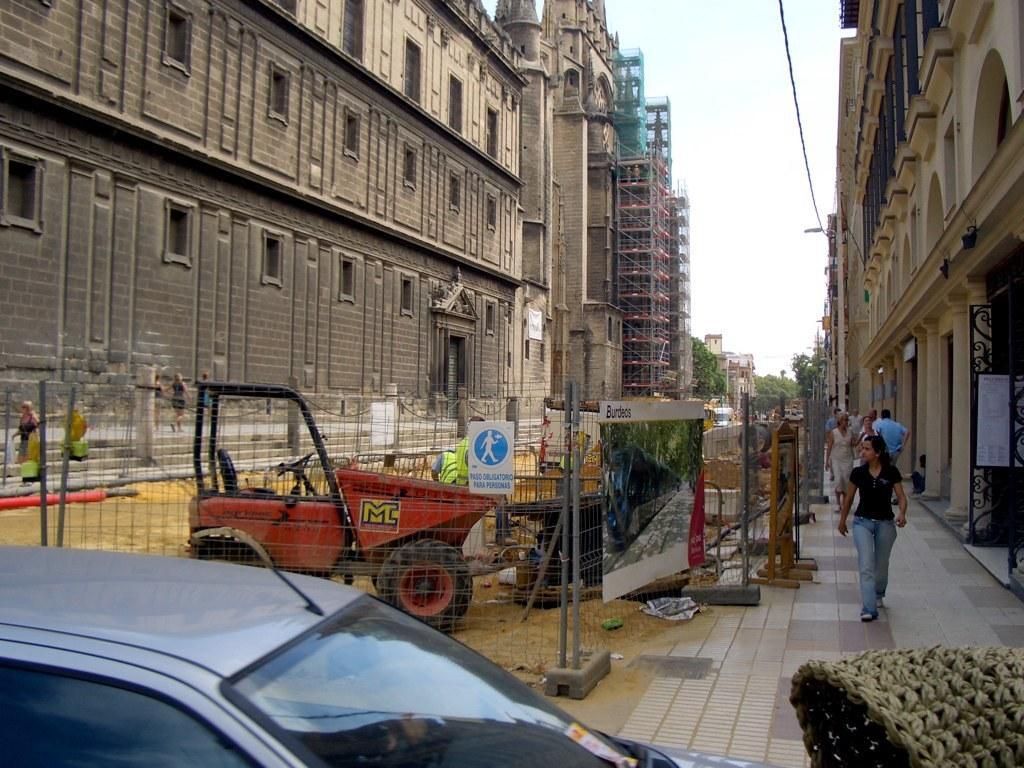Describe this image in one or two sentences. In this image we can see buildings under construction, buildings, persons walking on the road, motor vehicles, advertisement boards, sign boards, trees, cables, fences and sky. 